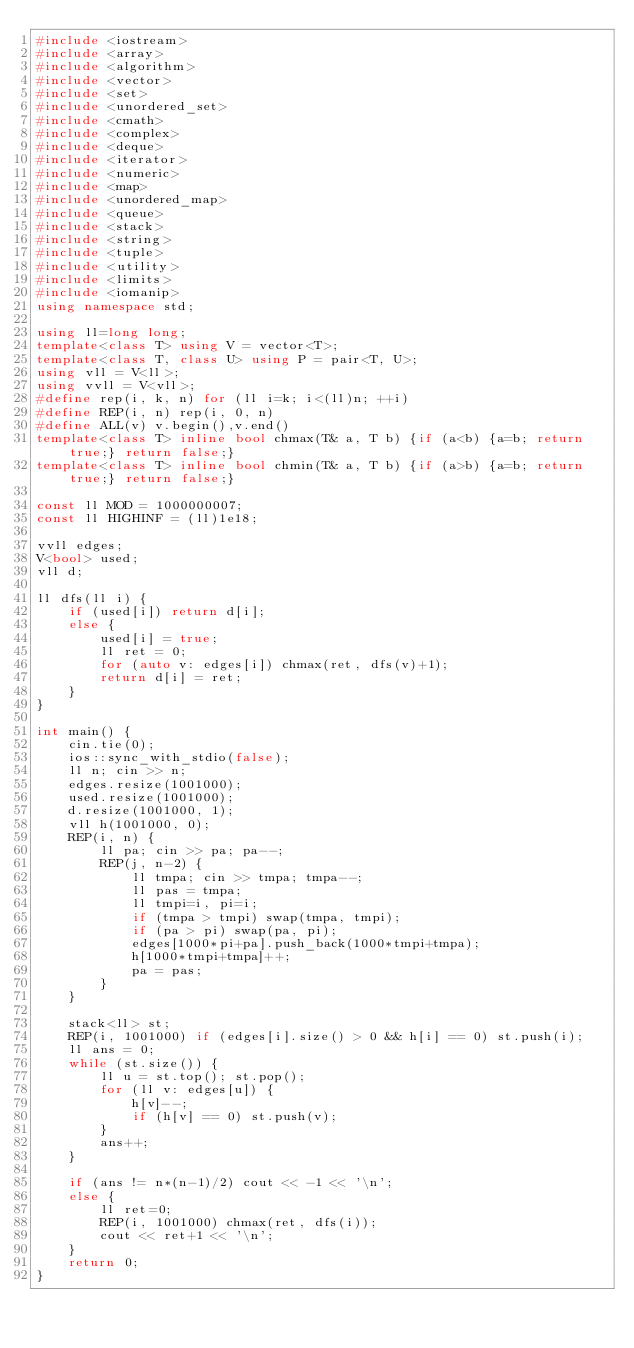<code> <loc_0><loc_0><loc_500><loc_500><_C++_>#include <iostream>
#include <array>
#include <algorithm>
#include <vector>
#include <set>
#include <unordered_set>
#include <cmath>
#include <complex>
#include <deque>
#include <iterator>
#include <numeric>
#include <map>
#include <unordered_map>
#include <queue>
#include <stack>
#include <string>
#include <tuple>
#include <utility>
#include <limits>
#include <iomanip>
using namespace std;

using ll=long long;
template<class T> using V = vector<T>;
template<class T, class U> using P = pair<T, U>;
using vll = V<ll>;
using vvll = V<vll>;
#define rep(i, k, n) for (ll i=k; i<(ll)n; ++i)
#define REP(i, n) rep(i, 0, n)
#define ALL(v) v.begin(),v.end()
template<class T> inline bool chmax(T& a, T b) {if (a<b) {a=b; return true;} return false;}
template<class T> inline bool chmin(T& a, T b) {if (a>b) {a=b; return true;} return false;}

const ll MOD = 1000000007;
const ll HIGHINF = (ll)1e18;

vvll edges;
V<bool> used;
vll d;

ll dfs(ll i) {
    if (used[i]) return d[i];
    else {
        used[i] = true;
        ll ret = 0;
        for (auto v: edges[i]) chmax(ret, dfs(v)+1);
        return d[i] = ret;
    }
}

int main() {
    cin.tie(0);
    ios::sync_with_stdio(false);
    ll n; cin >> n;
    edges.resize(1001000);
    used.resize(1001000);
    d.resize(1001000, 1);
    vll h(1001000, 0);
    REP(i, n) {
        ll pa; cin >> pa; pa--;
        REP(j, n-2) {
            ll tmpa; cin >> tmpa; tmpa--;
            ll pas = tmpa;
            ll tmpi=i, pi=i;
            if (tmpa > tmpi) swap(tmpa, tmpi);
            if (pa > pi) swap(pa, pi);
            edges[1000*pi+pa].push_back(1000*tmpi+tmpa);
            h[1000*tmpi+tmpa]++;
            pa = pas;
        }
    }

    stack<ll> st;
    REP(i, 1001000) if (edges[i].size() > 0 && h[i] == 0) st.push(i);
    ll ans = 0;
    while (st.size()) {
        ll u = st.top(); st.pop();
        for (ll v: edges[u]) {
            h[v]--;
            if (h[v] == 0) st.push(v);
        }
        ans++;
    }

    if (ans != n*(n-1)/2) cout << -1 << '\n';
    else {
        ll ret=0;
        REP(i, 1001000) chmax(ret, dfs(i));
        cout << ret+1 << '\n';
    }
    return 0;
}
</code> 